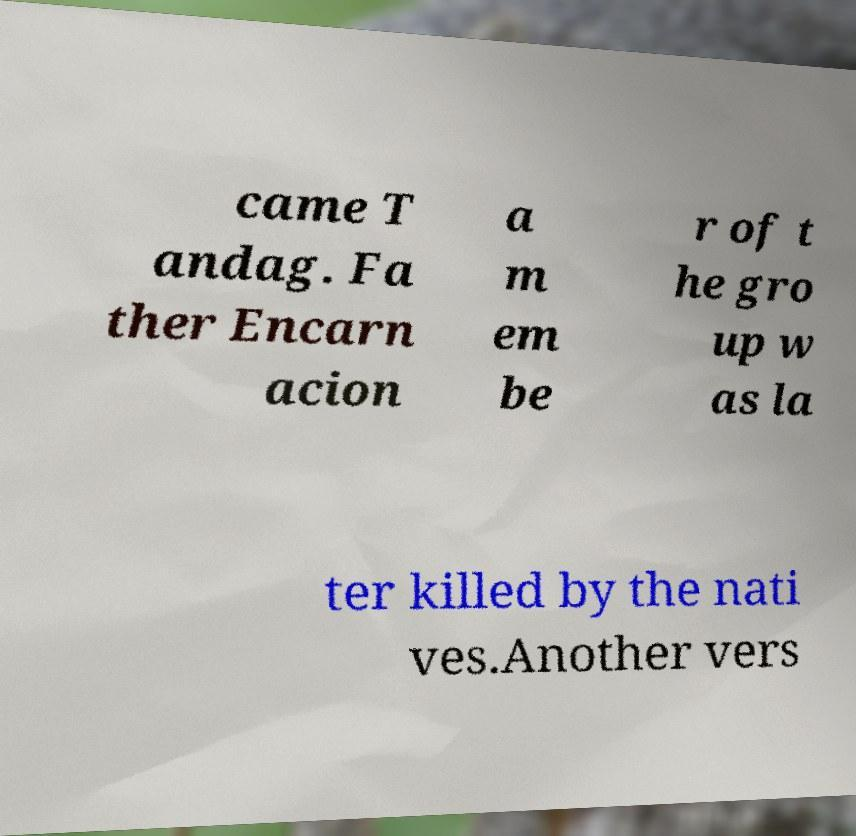Can you read and provide the text displayed in the image?This photo seems to have some interesting text. Can you extract and type it out for me? came T andag. Fa ther Encarn acion a m em be r of t he gro up w as la ter killed by the nati ves.Another vers 